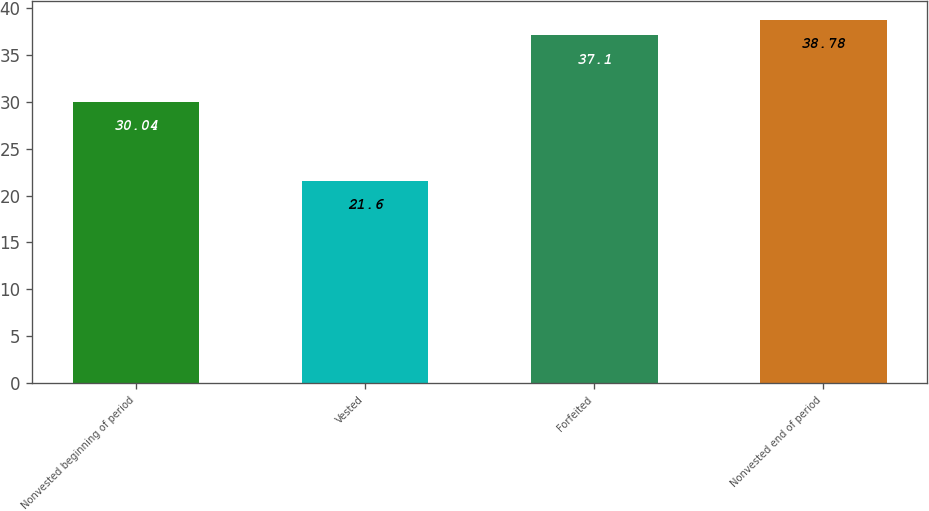Convert chart to OTSL. <chart><loc_0><loc_0><loc_500><loc_500><bar_chart><fcel>Nonvested beginning of period<fcel>Vested<fcel>Forfeited<fcel>Nonvested end of period<nl><fcel>30.04<fcel>21.6<fcel>37.1<fcel>38.78<nl></chart> 